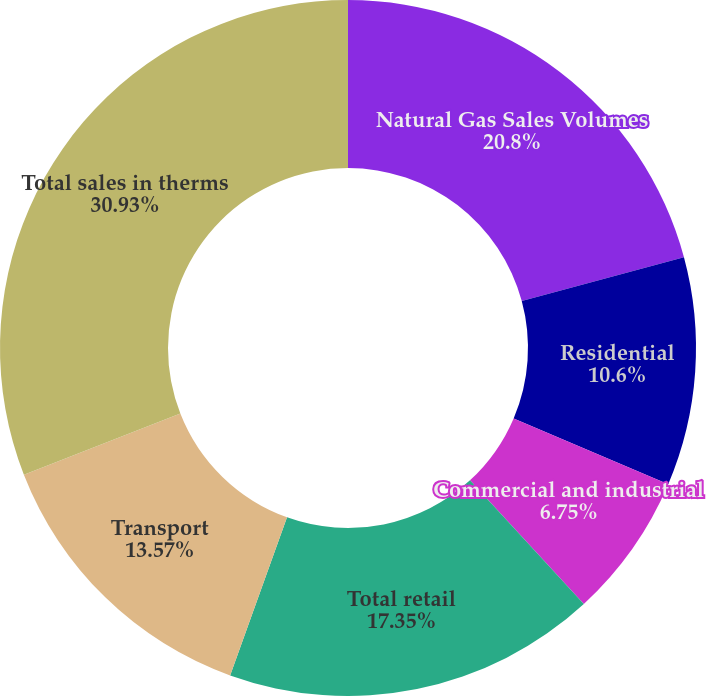Convert chart. <chart><loc_0><loc_0><loc_500><loc_500><pie_chart><fcel>Natural Gas Sales Volumes<fcel>Residential<fcel>Commercial and industrial<fcel>Total retail<fcel>Transport<fcel>Total sales in therms<nl><fcel>20.8%<fcel>10.6%<fcel>6.75%<fcel>17.35%<fcel>13.57%<fcel>30.93%<nl></chart> 